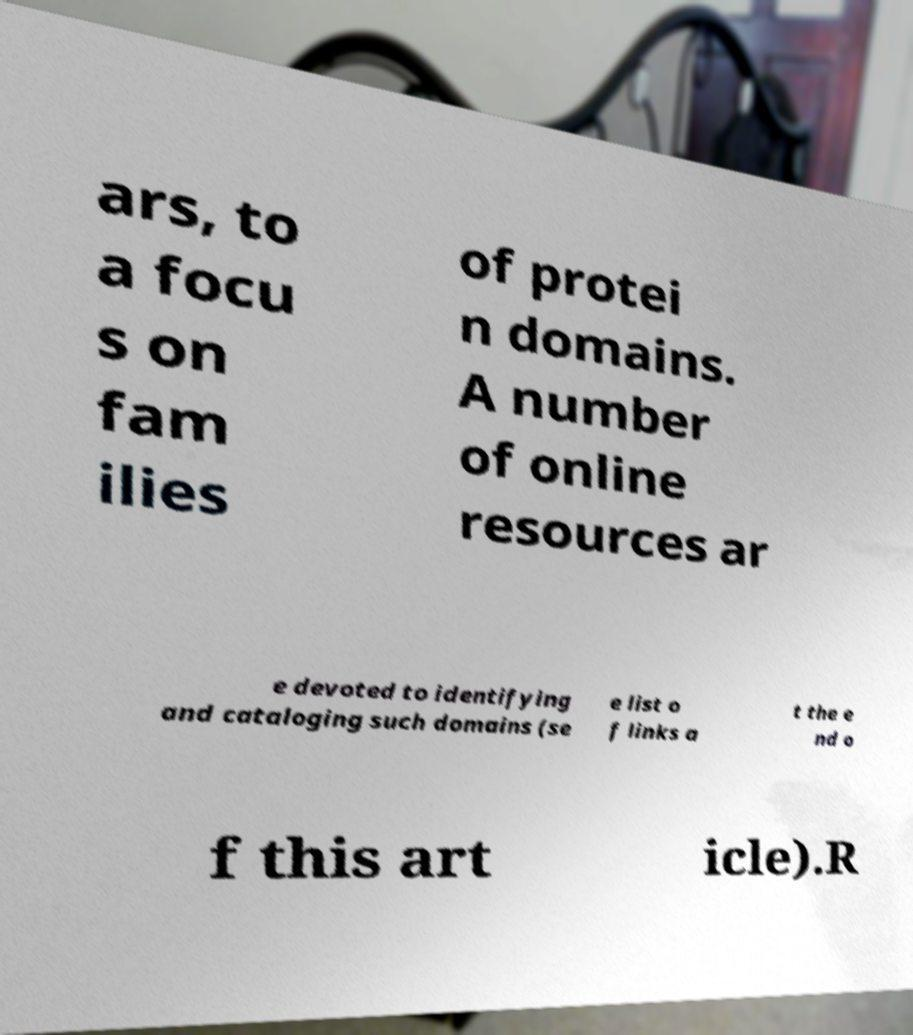Please read and relay the text visible in this image. What does it say? ars, to a focu s on fam ilies of protei n domains. A number of online resources ar e devoted to identifying and cataloging such domains (se e list o f links a t the e nd o f this art icle).R 